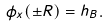Convert formula to latex. <formula><loc_0><loc_0><loc_500><loc_500>\phi _ { x } ( \pm R ) = h _ { B } .</formula> 